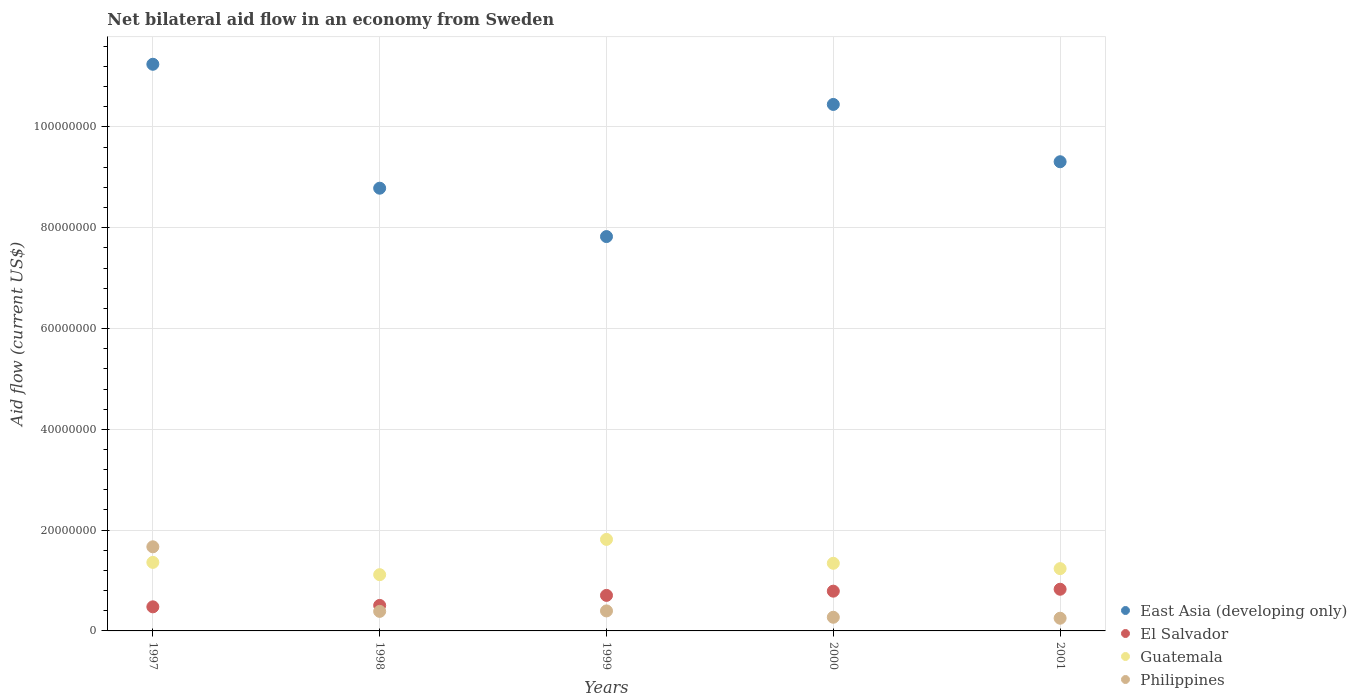Is the number of dotlines equal to the number of legend labels?
Offer a terse response. Yes. What is the net bilateral aid flow in Guatemala in 2000?
Offer a terse response. 1.34e+07. Across all years, what is the maximum net bilateral aid flow in Guatemala?
Offer a very short reply. 1.82e+07. Across all years, what is the minimum net bilateral aid flow in East Asia (developing only)?
Make the answer very short. 7.82e+07. In which year was the net bilateral aid flow in East Asia (developing only) maximum?
Keep it short and to the point. 1997. What is the total net bilateral aid flow in El Salvador in the graph?
Make the answer very short. 3.30e+07. What is the difference between the net bilateral aid flow in Philippines in 1997 and that in 2000?
Your answer should be very brief. 1.40e+07. What is the difference between the net bilateral aid flow in Guatemala in 1997 and the net bilateral aid flow in East Asia (developing only) in 1999?
Make the answer very short. -6.46e+07. What is the average net bilateral aid flow in Guatemala per year?
Make the answer very short. 1.37e+07. In the year 1997, what is the difference between the net bilateral aid flow in Guatemala and net bilateral aid flow in El Salvador?
Provide a succinct answer. 8.82e+06. In how many years, is the net bilateral aid flow in Philippines greater than 64000000 US$?
Your response must be concise. 0. What is the ratio of the net bilateral aid flow in Philippines in 1998 to that in 2001?
Your response must be concise. 1.54. What is the difference between the highest and the second highest net bilateral aid flow in East Asia (developing only)?
Ensure brevity in your answer.  7.97e+06. In how many years, is the net bilateral aid flow in Philippines greater than the average net bilateral aid flow in Philippines taken over all years?
Make the answer very short. 1. Is the sum of the net bilateral aid flow in Philippines in 2000 and 2001 greater than the maximum net bilateral aid flow in Guatemala across all years?
Your answer should be very brief. No. Is it the case that in every year, the sum of the net bilateral aid flow in El Salvador and net bilateral aid flow in Philippines  is greater than the net bilateral aid flow in East Asia (developing only)?
Your response must be concise. No. Does the net bilateral aid flow in Philippines monotonically increase over the years?
Give a very brief answer. No. Is the net bilateral aid flow in El Salvador strictly greater than the net bilateral aid flow in East Asia (developing only) over the years?
Keep it short and to the point. No. Is the net bilateral aid flow in East Asia (developing only) strictly less than the net bilateral aid flow in El Salvador over the years?
Give a very brief answer. No. Does the graph contain grids?
Your answer should be very brief. Yes. Where does the legend appear in the graph?
Your answer should be compact. Bottom right. How many legend labels are there?
Your response must be concise. 4. How are the legend labels stacked?
Provide a succinct answer. Vertical. What is the title of the graph?
Your answer should be compact. Net bilateral aid flow in an economy from Sweden. What is the label or title of the X-axis?
Make the answer very short. Years. What is the Aid flow (current US$) of East Asia (developing only) in 1997?
Ensure brevity in your answer.  1.12e+08. What is the Aid flow (current US$) of El Salvador in 1997?
Keep it short and to the point. 4.78e+06. What is the Aid flow (current US$) in Guatemala in 1997?
Offer a terse response. 1.36e+07. What is the Aid flow (current US$) in Philippines in 1997?
Provide a succinct answer. 1.67e+07. What is the Aid flow (current US$) in East Asia (developing only) in 1998?
Make the answer very short. 8.78e+07. What is the Aid flow (current US$) in El Salvador in 1998?
Your response must be concise. 5.06e+06. What is the Aid flow (current US$) of Guatemala in 1998?
Your answer should be very brief. 1.12e+07. What is the Aid flow (current US$) in Philippines in 1998?
Make the answer very short. 3.88e+06. What is the Aid flow (current US$) in East Asia (developing only) in 1999?
Offer a terse response. 7.82e+07. What is the Aid flow (current US$) of El Salvador in 1999?
Your answer should be compact. 7.05e+06. What is the Aid flow (current US$) in Guatemala in 1999?
Your response must be concise. 1.82e+07. What is the Aid flow (current US$) in Philippines in 1999?
Offer a terse response. 3.97e+06. What is the Aid flow (current US$) in East Asia (developing only) in 2000?
Give a very brief answer. 1.04e+08. What is the Aid flow (current US$) in El Salvador in 2000?
Your answer should be compact. 7.89e+06. What is the Aid flow (current US$) in Guatemala in 2000?
Provide a succinct answer. 1.34e+07. What is the Aid flow (current US$) in Philippines in 2000?
Offer a terse response. 2.71e+06. What is the Aid flow (current US$) in East Asia (developing only) in 2001?
Offer a terse response. 9.31e+07. What is the Aid flow (current US$) of El Salvador in 2001?
Give a very brief answer. 8.27e+06. What is the Aid flow (current US$) of Guatemala in 2001?
Your answer should be very brief. 1.24e+07. What is the Aid flow (current US$) of Philippines in 2001?
Ensure brevity in your answer.  2.52e+06. Across all years, what is the maximum Aid flow (current US$) of East Asia (developing only)?
Keep it short and to the point. 1.12e+08. Across all years, what is the maximum Aid flow (current US$) of El Salvador?
Provide a short and direct response. 8.27e+06. Across all years, what is the maximum Aid flow (current US$) of Guatemala?
Provide a succinct answer. 1.82e+07. Across all years, what is the maximum Aid flow (current US$) in Philippines?
Your answer should be very brief. 1.67e+07. Across all years, what is the minimum Aid flow (current US$) of East Asia (developing only)?
Your answer should be very brief. 7.82e+07. Across all years, what is the minimum Aid flow (current US$) of El Salvador?
Your answer should be compact. 4.78e+06. Across all years, what is the minimum Aid flow (current US$) in Guatemala?
Provide a short and direct response. 1.12e+07. Across all years, what is the minimum Aid flow (current US$) in Philippines?
Keep it short and to the point. 2.52e+06. What is the total Aid flow (current US$) of East Asia (developing only) in the graph?
Your answer should be very brief. 4.76e+08. What is the total Aid flow (current US$) in El Salvador in the graph?
Offer a very short reply. 3.30e+07. What is the total Aid flow (current US$) of Guatemala in the graph?
Keep it short and to the point. 6.87e+07. What is the total Aid flow (current US$) of Philippines in the graph?
Provide a succinct answer. 2.98e+07. What is the difference between the Aid flow (current US$) in East Asia (developing only) in 1997 and that in 1998?
Ensure brevity in your answer.  2.46e+07. What is the difference between the Aid flow (current US$) of El Salvador in 1997 and that in 1998?
Provide a short and direct response. -2.80e+05. What is the difference between the Aid flow (current US$) in Guatemala in 1997 and that in 1998?
Give a very brief answer. 2.44e+06. What is the difference between the Aid flow (current US$) in Philippines in 1997 and that in 1998?
Your answer should be compact. 1.28e+07. What is the difference between the Aid flow (current US$) in East Asia (developing only) in 1997 and that in 1999?
Your answer should be very brief. 3.42e+07. What is the difference between the Aid flow (current US$) in El Salvador in 1997 and that in 1999?
Your response must be concise. -2.27e+06. What is the difference between the Aid flow (current US$) of Guatemala in 1997 and that in 1999?
Give a very brief answer. -4.56e+06. What is the difference between the Aid flow (current US$) of Philippines in 1997 and that in 1999?
Provide a succinct answer. 1.27e+07. What is the difference between the Aid flow (current US$) of East Asia (developing only) in 1997 and that in 2000?
Provide a short and direct response. 7.97e+06. What is the difference between the Aid flow (current US$) in El Salvador in 1997 and that in 2000?
Provide a succinct answer. -3.11e+06. What is the difference between the Aid flow (current US$) of Guatemala in 1997 and that in 2000?
Your response must be concise. 1.80e+05. What is the difference between the Aid flow (current US$) of Philippines in 1997 and that in 2000?
Ensure brevity in your answer.  1.40e+07. What is the difference between the Aid flow (current US$) in East Asia (developing only) in 1997 and that in 2001?
Ensure brevity in your answer.  1.93e+07. What is the difference between the Aid flow (current US$) of El Salvador in 1997 and that in 2001?
Your answer should be compact. -3.49e+06. What is the difference between the Aid flow (current US$) of Guatemala in 1997 and that in 2001?
Your answer should be very brief. 1.24e+06. What is the difference between the Aid flow (current US$) of Philippines in 1997 and that in 2001?
Offer a very short reply. 1.42e+07. What is the difference between the Aid flow (current US$) in East Asia (developing only) in 1998 and that in 1999?
Your answer should be very brief. 9.60e+06. What is the difference between the Aid flow (current US$) in El Salvador in 1998 and that in 1999?
Ensure brevity in your answer.  -1.99e+06. What is the difference between the Aid flow (current US$) in Guatemala in 1998 and that in 1999?
Give a very brief answer. -7.00e+06. What is the difference between the Aid flow (current US$) in East Asia (developing only) in 1998 and that in 2000?
Offer a terse response. -1.66e+07. What is the difference between the Aid flow (current US$) of El Salvador in 1998 and that in 2000?
Give a very brief answer. -2.83e+06. What is the difference between the Aid flow (current US$) in Guatemala in 1998 and that in 2000?
Ensure brevity in your answer.  -2.26e+06. What is the difference between the Aid flow (current US$) in Philippines in 1998 and that in 2000?
Ensure brevity in your answer.  1.17e+06. What is the difference between the Aid flow (current US$) in East Asia (developing only) in 1998 and that in 2001?
Provide a succinct answer. -5.25e+06. What is the difference between the Aid flow (current US$) of El Salvador in 1998 and that in 2001?
Make the answer very short. -3.21e+06. What is the difference between the Aid flow (current US$) of Guatemala in 1998 and that in 2001?
Make the answer very short. -1.20e+06. What is the difference between the Aid flow (current US$) of Philippines in 1998 and that in 2001?
Your answer should be compact. 1.36e+06. What is the difference between the Aid flow (current US$) in East Asia (developing only) in 1999 and that in 2000?
Your response must be concise. -2.62e+07. What is the difference between the Aid flow (current US$) in El Salvador in 1999 and that in 2000?
Offer a terse response. -8.40e+05. What is the difference between the Aid flow (current US$) of Guatemala in 1999 and that in 2000?
Your answer should be compact. 4.74e+06. What is the difference between the Aid flow (current US$) of Philippines in 1999 and that in 2000?
Provide a succinct answer. 1.26e+06. What is the difference between the Aid flow (current US$) of East Asia (developing only) in 1999 and that in 2001?
Give a very brief answer. -1.48e+07. What is the difference between the Aid flow (current US$) in El Salvador in 1999 and that in 2001?
Your answer should be very brief. -1.22e+06. What is the difference between the Aid flow (current US$) in Guatemala in 1999 and that in 2001?
Offer a terse response. 5.80e+06. What is the difference between the Aid flow (current US$) of Philippines in 1999 and that in 2001?
Offer a terse response. 1.45e+06. What is the difference between the Aid flow (current US$) in East Asia (developing only) in 2000 and that in 2001?
Provide a succinct answer. 1.14e+07. What is the difference between the Aid flow (current US$) of El Salvador in 2000 and that in 2001?
Give a very brief answer. -3.80e+05. What is the difference between the Aid flow (current US$) of Guatemala in 2000 and that in 2001?
Keep it short and to the point. 1.06e+06. What is the difference between the Aid flow (current US$) in Philippines in 2000 and that in 2001?
Your answer should be compact. 1.90e+05. What is the difference between the Aid flow (current US$) of East Asia (developing only) in 1997 and the Aid flow (current US$) of El Salvador in 1998?
Make the answer very short. 1.07e+08. What is the difference between the Aid flow (current US$) of East Asia (developing only) in 1997 and the Aid flow (current US$) of Guatemala in 1998?
Ensure brevity in your answer.  1.01e+08. What is the difference between the Aid flow (current US$) in East Asia (developing only) in 1997 and the Aid flow (current US$) in Philippines in 1998?
Your answer should be compact. 1.09e+08. What is the difference between the Aid flow (current US$) in El Salvador in 1997 and the Aid flow (current US$) in Guatemala in 1998?
Your response must be concise. -6.38e+06. What is the difference between the Aid flow (current US$) of El Salvador in 1997 and the Aid flow (current US$) of Philippines in 1998?
Offer a terse response. 9.00e+05. What is the difference between the Aid flow (current US$) of Guatemala in 1997 and the Aid flow (current US$) of Philippines in 1998?
Provide a succinct answer. 9.72e+06. What is the difference between the Aid flow (current US$) in East Asia (developing only) in 1997 and the Aid flow (current US$) in El Salvador in 1999?
Offer a terse response. 1.05e+08. What is the difference between the Aid flow (current US$) in East Asia (developing only) in 1997 and the Aid flow (current US$) in Guatemala in 1999?
Offer a terse response. 9.43e+07. What is the difference between the Aid flow (current US$) of East Asia (developing only) in 1997 and the Aid flow (current US$) of Philippines in 1999?
Keep it short and to the point. 1.08e+08. What is the difference between the Aid flow (current US$) of El Salvador in 1997 and the Aid flow (current US$) of Guatemala in 1999?
Provide a short and direct response. -1.34e+07. What is the difference between the Aid flow (current US$) in El Salvador in 1997 and the Aid flow (current US$) in Philippines in 1999?
Give a very brief answer. 8.10e+05. What is the difference between the Aid flow (current US$) in Guatemala in 1997 and the Aid flow (current US$) in Philippines in 1999?
Provide a succinct answer. 9.63e+06. What is the difference between the Aid flow (current US$) in East Asia (developing only) in 1997 and the Aid flow (current US$) in El Salvador in 2000?
Provide a succinct answer. 1.05e+08. What is the difference between the Aid flow (current US$) of East Asia (developing only) in 1997 and the Aid flow (current US$) of Guatemala in 2000?
Your answer should be compact. 9.90e+07. What is the difference between the Aid flow (current US$) of East Asia (developing only) in 1997 and the Aid flow (current US$) of Philippines in 2000?
Make the answer very short. 1.10e+08. What is the difference between the Aid flow (current US$) in El Salvador in 1997 and the Aid flow (current US$) in Guatemala in 2000?
Provide a short and direct response. -8.64e+06. What is the difference between the Aid flow (current US$) in El Salvador in 1997 and the Aid flow (current US$) in Philippines in 2000?
Ensure brevity in your answer.  2.07e+06. What is the difference between the Aid flow (current US$) of Guatemala in 1997 and the Aid flow (current US$) of Philippines in 2000?
Offer a terse response. 1.09e+07. What is the difference between the Aid flow (current US$) of East Asia (developing only) in 1997 and the Aid flow (current US$) of El Salvador in 2001?
Provide a short and direct response. 1.04e+08. What is the difference between the Aid flow (current US$) in East Asia (developing only) in 1997 and the Aid flow (current US$) in Guatemala in 2001?
Give a very brief answer. 1.00e+08. What is the difference between the Aid flow (current US$) in East Asia (developing only) in 1997 and the Aid flow (current US$) in Philippines in 2001?
Give a very brief answer. 1.10e+08. What is the difference between the Aid flow (current US$) in El Salvador in 1997 and the Aid flow (current US$) in Guatemala in 2001?
Ensure brevity in your answer.  -7.58e+06. What is the difference between the Aid flow (current US$) in El Salvador in 1997 and the Aid flow (current US$) in Philippines in 2001?
Keep it short and to the point. 2.26e+06. What is the difference between the Aid flow (current US$) in Guatemala in 1997 and the Aid flow (current US$) in Philippines in 2001?
Provide a succinct answer. 1.11e+07. What is the difference between the Aid flow (current US$) in East Asia (developing only) in 1998 and the Aid flow (current US$) in El Salvador in 1999?
Your response must be concise. 8.08e+07. What is the difference between the Aid flow (current US$) of East Asia (developing only) in 1998 and the Aid flow (current US$) of Guatemala in 1999?
Provide a short and direct response. 6.97e+07. What is the difference between the Aid flow (current US$) of East Asia (developing only) in 1998 and the Aid flow (current US$) of Philippines in 1999?
Your answer should be very brief. 8.39e+07. What is the difference between the Aid flow (current US$) in El Salvador in 1998 and the Aid flow (current US$) in Guatemala in 1999?
Make the answer very short. -1.31e+07. What is the difference between the Aid flow (current US$) in El Salvador in 1998 and the Aid flow (current US$) in Philippines in 1999?
Give a very brief answer. 1.09e+06. What is the difference between the Aid flow (current US$) in Guatemala in 1998 and the Aid flow (current US$) in Philippines in 1999?
Your answer should be compact. 7.19e+06. What is the difference between the Aid flow (current US$) in East Asia (developing only) in 1998 and the Aid flow (current US$) in El Salvador in 2000?
Ensure brevity in your answer.  8.00e+07. What is the difference between the Aid flow (current US$) in East Asia (developing only) in 1998 and the Aid flow (current US$) in Guatemala in 2000?
Your answer should be compact. 7.44e+07. What is the difference between the Aid flow (current US$) of East Asia (developing only) in 1998 and the Aid flow (current US$) of Philippines in 2000?
Your answer should be compact. 8.51e+07. What is the difference between the Aid flow (current US$) of El Salvador in 1998 and the Aid flow (current US$) of Guatemala in 2000?
Make the answer very short. -8.36e+06. What is the difference between the Aid flow (current US$) in El Salvador in 1998 and the Aid flow (current US$) in Philippines in 2000?
Provide a short and direct response. 2.35e+06. What is the difference between the Aid flow (current US$) of Guatemala in 1998 and the Aid flow (current US$) of Philippines in 2000?
Make the answer very short. 8.45e+06. What is the difference between the Aid flow (current US$) of East Asia (developing only) in 1998 and the Aid flow (current US$) of El Salvador in 2001?
Provide a short and direct response. 7.96e+07. What is the difference between the Aid flow (current US$) in East Asia (developing only) in 1998 and the Aid flow (current US$) in Guatemala in 2001?
Offer a terse response. 7.55e+07. What is the difference between the Aid flow (current US$) of East Asia (developing only) in 1998 and the Aid flow (current US$) of Philippines in 2001?
Offer a very short reply. 8.53e+07. What is the difference between the Aid flow (current US$) in El Salvador in 1998 and the Aid flow (current US$) in Guatemala in 2001?
Your answer should be very brief. -7.30e+06. What is the difference between the Aid flow (current US$) of El Salvador in 1998 and the Aid flow (current US$) of Philippines in 2001?
Keep it short and to the point. 2.54e+06. What is the difference between the Aid flow (current US$) of Guatemala in 1998 and the Aid flow (current US$) of Philippines in 2001?
Provide a short and direct response. 8.64e+06. What is the difference between the Aid flow (current US$) in East Asia (developing only) in 1999 and the Aid flow (current US$) in El Salvador in 2000?
Your response must be concise. 7.04e+07. What is the difference between the Aid flow (current US$) of East Asia (developing only) in 1999 and the Aid flow (current US$) of Guatemala in 2000?
Make the answer very short. 6.48e+07. What is the difference between the Aid flow (current US$) in East Asia (developing only) in 1999 and the Aid flow (current US$) in Philippines in 2000?
Your answer should be compact. 7.55e+07. What is the difference between the Aid flow (current US$) in El Salvador in 1999 and the Aid flow (current US$) in Guatemala in 2000?
Keep it short and to the point. -6.37e+06. What is the difference between the Aid flow (current US$) in El Salvador in 1999 and the Aid flow (current US$) in Philippines in 2000?
Make the answer very short. 4.34e+06. What is the difference between the Aid flow (current US$) in Guatemala in 1999 and the Aid flow (current US$) in Philippines in 2000?
Your answer should be very brief. 1.54e+07. What is the difference between the Aid flow (current US$) in East Asia (developing only) in 1999 and the Aid flow (current US$) in El Salvador in 2001?
Your answer should be very brief. 7.00e+07. What is the difference between the Aid flow (current US$) of East Asia (developing only) in 1999 and the Aid flow (current US$) of Guatemala in 2001?
Provide a succinct answer. 6.59e+07. What is the difference between the Aid flow (current US$) in East Asia (developing only) in 1999 and the Aid flow (current US$) in Philippines in 2001?
Offer a terse response. 7.57e+07. What is the difference between the Aid flow (current US$) in El Salvador in 1999 and the Aid flow (current US$) in Guatemala in 2001?
Your answer should be very brief. -5.31e+06. What is the difference between the Aid flow (current US$) in El Salvador in 1999 and the Aid flow (current US$) in Philippines in 2001?
Keep it short and to the point. 4.53e+06. What is the difference between the Aid flow (current US$) in Guatemala in 1999 and the Aid flow (current US$) in Philippines in 2001?
Your response must be concise. 1.56e+07. What is the difference between the Aid flow (current US$) of East Asia (developing only) in 2000 and the Aid flow (current US$) of El Salvador in 2001?
Ensure brevity in your answer.  9.62e+07. What is the difference between the Aid flow (current US$) of East Asia (developing only) in 2000 and the Aid flow (current US$) of Guatemala in 2001?
Your answer should be very brief. 9.21e+07. What is the difference between the Aid flow (current US$) in East Asia (developing only) in 2000 and the Aid flow (current US$) in Philippines in 2001?
Your answer should be compact. 1.02e+08. What is the difference between the Aid flow (current US$) in El Salvador in 2000 and the Aid flow (current US$) in Guatemala in 2001?
Give a very brief answer. -4.47e+06. What is the difference between the Aid flow (current US$) in El Salvador in 2000 and the Aid flow (current US$) in Philippines in 2001?
Your answer should be compact. 5.37e+06. What is the difference between the Aid flow (current US$) in Guatemala in 2000 and the Aid flow (current US$) in Philippines in 2001?
Ensure brevity in your answer.  1.09e+07. What is the average Aid flow (current US$) of East Asia (developing only) per year?
Provide a succinct answer. 9.52e+07. What is the average Aid flow (current US$) of El Salvador per year?
Offer a very short reply. 6.61e+06. What is the average Aid flow (current US$) of Guatemala per year?
Your response must be concise. 1.37e+07. What is the average Aid flow (current US$) of Philippines per year?
Provide a short and direct response. 5.95e+06. In the year 1997, what is the difference between the Aid flow (current US$) in East Asia (developing only) and Aid flow (current US$) in El Salvador?
Keep it short and to the point. 1.08e+08. In the year 1997, what is the difference between the Aid flow (current US$) in East Asia (developing only) and Aid flow (current US$) in Guatemala?
Give a very brief answer. 9.88e+07. In the year 1997, what is the difference between the Aid flow (current US$) in East Asia (developing only) and Aid flow (current US$) in Philippines?
Your answer should be compact. 9.58e+07. In the year 1997, what is the difference between the Aid flow (current US$) in El Salvador and Aid flow (current US$) in Guatemala?
Provide a short and direct response. -8.82e+06. In the year 1997, what is the difference between the Aid flow (current US$) of El Salvador and Aid flow (current US$) of Philippines?
Offer a terse response. -1.19e+07. In the year 1997, what is the difference between the Aid flow (current US$) of Guatemala and Aid flow (current US$) of Philippines?
Your response must be concise. -3.09e+06. In the year 1998, what is the difference between the Aid flow (current US$) in East Asia (developing only) and Aid flow (current US$) in El Salvador?
Provide a short and direct response. 8.28e+07. In the year 1998, what is the difference between the Aid flow (current US$) in East Asia (developing only) and Aid flow (current US$) in Guatemala?
Give a very brief answer. 7.67e+07. In the year 1998, what is the difference between the Aid flow (current US$) of East Asia (developing only) and Aid flow (current US$) of Philippines?
Offer a terse response. 8.40e+07. In the year 1998, what is the difference between the Aid flow (current US$) in El Salvador and Aid flow (current US$) in Guatemala?
Provide a succinct answer. -6.10e+06. In the year 1998, what is the difference between the Aid flow (current US$) in El Salvador and Aid flow (current US$) in Philippines?
Make the answer very short. 1.18e+06. In the year 1998, what is the difference between the Aid flow (current US$) in Guatemala and Aid flow (current US$) in Philippines?
Your answer should be very brief. 7.28e+06. In the year 1999, what is the difference between the Aid flow (current US$) of East Asia (developing only) and Aid flow (current US$) of El Salvador?
Ensure brevity in your answer.  7.12e+07. In the year 1999, what is the difference between the Aid flow (current US$) in East Asia (developing only) and Aid flow (current US$) in Guatemala?
Your answer should be very brief. 6.01e+07. In the year 1999, what is the difference between the Aid flow (current US$) of East Asia (developing only) and Aid flow (current US$) of Philippines?
Ensure brevity in your answer.  7.43e+07. In the year 1999, what is the difference between the Aid flow (current US$) of El Salvador and Aid flow (current US$) of Guatemala?
Make the answer very short. -1.11e+07. In the year 1999, what is the difference between the Aid flow (current US$) in El Salvador and Aid flow (current US$) in Philippines?
Your response must be concise. 3.08e+06. In the year 1999, what is the difference between the Aid flow (current US$) of Guatemala and Aid flow (current US$) of Philippines?
Keep it short and to the point. 1.42e+07. In the year 2000, what is the difference between the Aid flow (current US$) in East Asia (developing only) and Aid flow (current US$) in El Salvador?
Ensure brevity in your answer.  9.66e+07. In the year 2000, what is the difference between the Aid flow (current US$) in East Asia (developing only) and Aid flow (current US$) in Guatemala?
Your answer should be compact. 9.10e+07. In the year 2000, what is the difference between the Aid flow (current US$) of East Asia (developing only) and Aid flow (current US$) of Philippines?
Keep it short and to the point. 1.02e+08. In the year 2000, what is the difference between the Aid flow (current US$) in El Salvador and Aid flow (current US$) in Guatemala?
Offer a very short reply. -5.53e+06. In the year 2000, what is the difference between the Aid flow (current US$) of El Salvador and Aid flow (current US$) of Philippines?
Keep it short and to the point. 5.18e+06. In the year 2000, what is the difference between the Aid flow (current US$) of Guatemala and Aid flow (current US$) of Philippines?
Offer a terse response. 1.07e+07. In the year 2001, what is the difference between the Aid flow (current US$) in East Asia (developing only) and Aid flow (current US$) in El Salvador?
Give a very brief answer. 8.48e+07. In the year 2001, what is the difference between the Aid flow (current US$) in East Asia (developing only) and Aid flow (current US$) in Guatemala?
Offer a very short reply. 8.07e+07. In the year 2001, what is the difference between the Aid flow (current US$) of East Asia (developing only) and Aid flow (current US$) of Philippines?
Provide a short and direct response. 9.06e+07. In the year 2001, what is the difference between the Aid flow (current US$) of El Salvador and Aid flow (current US$) of Guatemala?
Provide a succinct answer. -4.09e+06. In the year 2001, what is the difference between the Aid flow (current US$) in El Salvador and Aid flow (current US$) in Philippines?
Provide a succinct answer. 5.75e+06. In the year 2001, what is the difference between the Aid flow (current US$) in Guatemala and Aid flow (current US$) in Philippines?
Offer a very short reply. 9.84e+06. What is the ratio of the Aid flow (current US$) of East Asia (developing only) in 1997 to that in 1998?
Provide a short and direct response. 1.28. What is the ratio of the Aid flow (current US$) of El Salvador in 1997 to that in 1998?
Offer a terse response. 0.94. What is the ratio of the Aid flow (current US$) of Guatemala in 1997 to that in 1998?
Offer a terse response. 1.22. What is the ratio of the Aid flow (current US$) in Philippines in 1997 to that in 1998?
Offer a very short reply. 4.3. What is the ratio of the Aid flow (current US$) of East Asia (developing only) in 1997 to that in 1999?
Provide a short and direct response. 1.44. What is the ratio of the Aid flow (current US$) in El Salvador in 1997 to that in 1999?
Keep it short and to the point. 0.68. What is the ratio of the Aid flow (current US$) of Guatemala in 1997 to that in 1999?
Offer a terse response. 0.75. What is the ratio of the Aid flow (current US$) of Philippines in 1997 to that in 1999?
Ensure brevity in your answer.  4.2. What is the ratio of the Aid flow (current US$) in East Asia (developing only) in 1997 to that in 2000?
Your response must be concise. 1.08. What is the ratio of the Aid flow (current US$) in El Salvador in 1997 to that in 2000?
Offer a terse response. 0.61. What is the ratio of the Aid flow (current US$) in Guatemala in 1997 to that in 2000?
Offer a terse response. 1.01. What is the ratio of the Aid flow (current US$) in Philippines in 1997 to that in 2000?
Offer a terse response. 6.16. What is the ratio of the Aid flow (current US$) in East Asia (developing only) in 1997 to that in 2001?
Your response must be concise. 1.21. What is the ratio of the Aid flow (current US$) in El Salvador in 1997 to that in 2001?
Your answer should be very brief. 0.58. What is the ratio of the Aid flow (current US$) in Guatemala in 1997 to that in 2001?
Offer a very short reply. 1.1. What is the ratio of the Aid flow (current US$) of Philippines in 1997 to that in 2001?
Make the answer very short. 6.62. What is the ratio of the Aid flow (current US$) of East Asia (developing only) in 1998 to that in 1999?
Provide a short and direct response. 1.12. What is the ratio of the Aid flow (current US$) in El Salvador in 1998 to that in 1999?
Keep it short and to the point. 0.72. What is the ratio of the Aid flow (current US$) in Guatemala in 1998 to that in 1999?
Give a very brief answer. 0.61. What is the ratio of the Aid flow (current US$) in Philippines in 1998 to that in 1999?
Your response must be concise. 0.98. What is the ratio of the Aid flow (current US$) in East Asia (developing only) in 1998 to that in 2000?
Your answer should be very brief. 0.84. What is the ratio of the Aid flow (current US$) in El Salvador in 1998 to that in 2000?
Make the answer very short. 0.64. What is the ratio of the Aid flow (current US$) in Guatemala in 1998 to that in 2000?
Provide a succinct answer. 0.83. What is the ratio of the Aid flow (current US$) in Philippines in 1998 to that in 2000?
Ensure brevity in your answer.  1.43. What is the ratio of the Aid flow (current US$) of East Asia (developing only) in 1998 to that in 2001?
Keep it short and to the point. 0.94. What is the ratio of the Aid flow (current US$) in El Salvador in 1998 to that in 2001?
Provide a short and direct response. 0.61. What is the ratio of the Aid flow (current US$) in Guatemala in 1998 to that in 2001?
Keep it short and to the point. 0.9. What is the ratio of the Aid flow (current US$) in Philippines in 1998 to that in 2001?
Your answer should be very brief. 1.54. What is the ratio of the Aid flow (current US$) of East Asia (developing only) in 1999 to that in 2000?
Offer a very short reply. 0.75. What is the ratio of the Aid flow (current US$) of El Salvador in 1999 to that in 2000?
Keep it short and to the point. 0.89. What is the ratio of the Aid flow (current US$) of Guatemala in 1999 to that in 2000?
Provide a short and direct response. 1.35. What is the ratio of the Aid flow (current US$) in Philippines in 1999 to that in 2000?
Ensure brevity in your answer.  1.46. What is the ratio of the Aid flow (current US$) of East Asia (developing only) in 1999 to that in 2001?
Your answer should be very brief. 0.84. What is the ratio of the Aid flow (current US$) in El Salvador in 1999 to that in 2001?
Provide a succinct answer. 0.85. What is the ratio of the Aid flow (current US$) of Guatemala in 1999 to that in 2001?
Your response must be concise. 1.47. What is the ratio of the Aid flow (current US$) of Philippines in 1999 to that in 2001?
Provide a short and direct response. 1.58. What is the ratio of the Aid flow (current US$) of East Asia (developing only) in 2000 to that in 2001?
Provide a succinct answer. 1.12. What is the ratio of the Aid flow (current US$) of El Salvador in 2000 to that in 2001?
Your answer should be compact. 0.95. What is the ratio of the Aid flow (current US$) of Guatemala in 2000 to that in 2001?
Your answer should be compact. 1.09. What is the ratio of the Aid flow (current US$) in Philippines in 2000 to that in 2001?
Your response must be concise. 1.08. What is the difference between the highest and the second highest Aid flow (current US$) in East Asia (developing only)?
Your response must be concise. 7.97e+06. What is the difference between the highest and the second highest Aid flow (current US$) in Guatemala?
Give a very brief answer. 4.56e+06. What is the difference between the highest and the second highest Aid flow (current US$) of Philippines?
Ensure brevity in your answer.  1.27e+07. What is the difference between the highest and the lowest Aid flow (current US$) in East Asia (developing only)?
Keep it short and to the point. 3.42e+07. What is the difference between the highest and the lowest Aid flow (current US$) of El Salvador?
Offer a terse response. 3.49e+06. What is the difference between the highest and the lowest Aid flow (current US$) in Guatemala?
Provide a short and direct response. 7.00e+06. What is the difference between the highest and the lowest Aid flow (current US$) of Philippines?
Provide a succinct answer. 1.42e+07. 